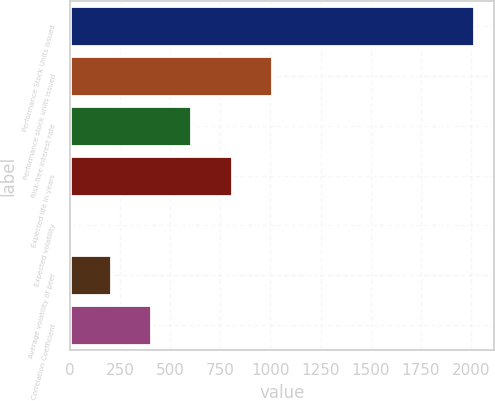<chart> <loc_0><loc_0><loc_500><loc_500><bar_chart><fcel>Performance Stock Units Issued<fcel>Performance stock units issued<fcel>Risk-free interest rate<fcel>Expected life in years<fcel>Expected volatility<fcel>Average volatility of peer<fcel>Correlation Coefficient<nl><fcel>2017<fcel>1008.61<fcel>605.25<fcel>806.93<fcel>0.21<fcel>201.89<fcel>403.57<nl></chart> 